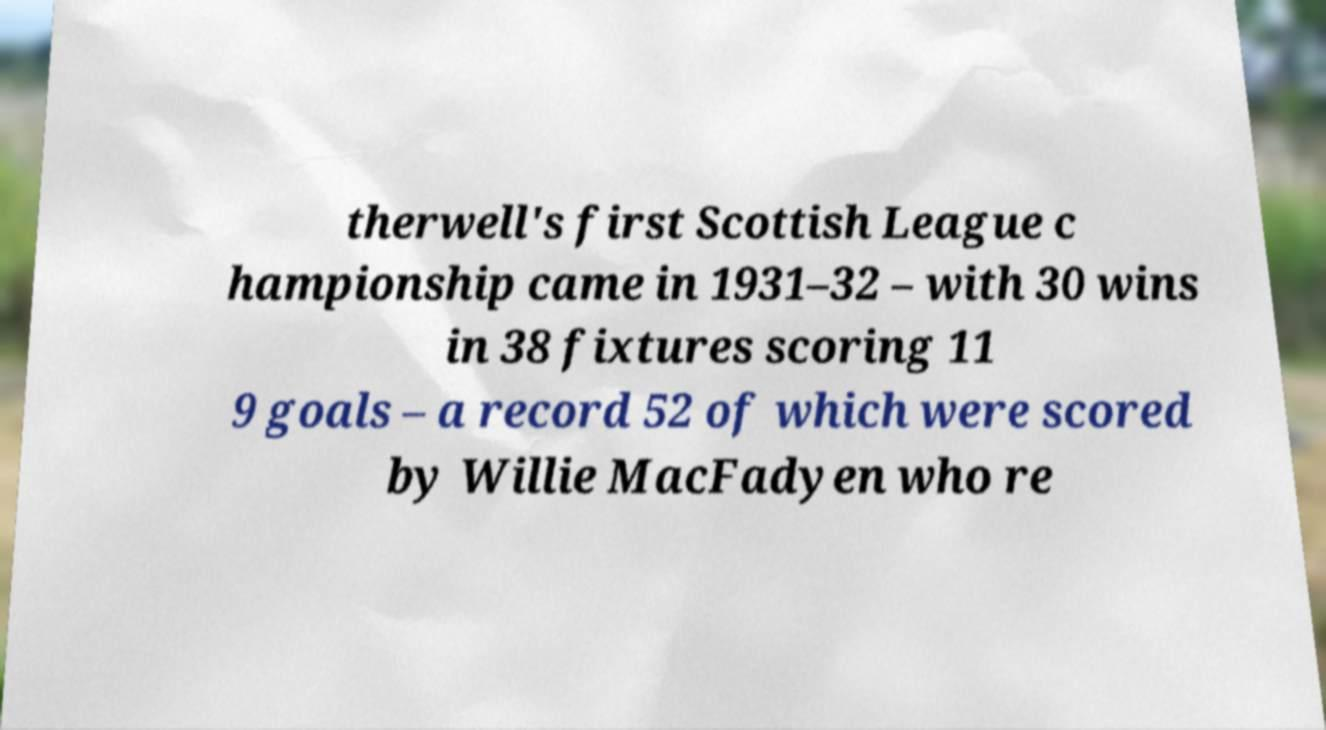What messages or text are displayed in this image? I need them in a readable, typed format. therwell's first Scottish League c hampionship came in 1931–32 – with 30 wins in 38 fixtures scoring 11 9 goals – a record 52 of which were scored by Willie MacFadyen who re 